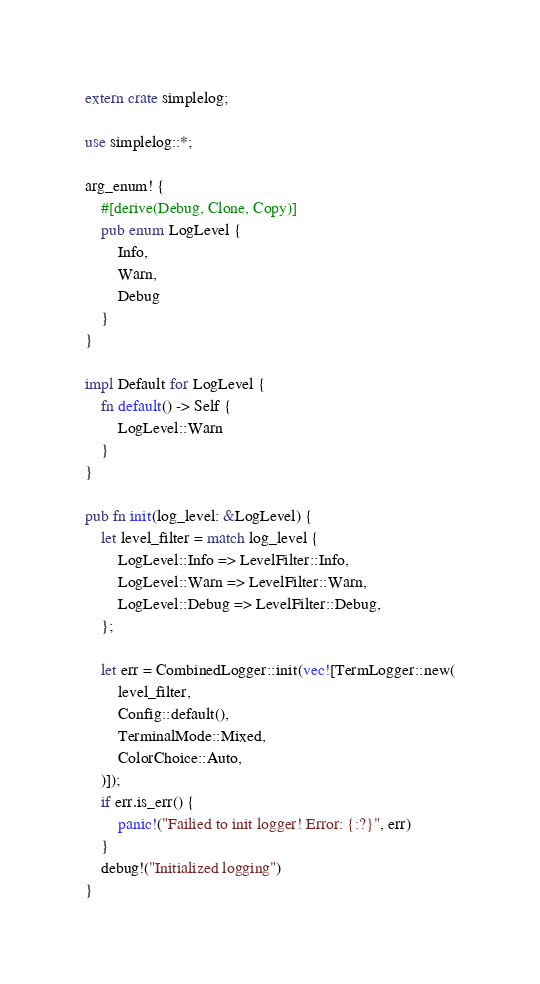Convert code to text. <code><loc_0><loc_0><loc_500><loc_500><_Rust_>extern crate simplelog;

use simplelog::*;

arg_enum! {
    #[derive(Debug, Clone, Copy)]
    pub enum LogLevel {
        Info,
        Warn,
        Debug
    }
}

impl Default for LogLevel {
    fn default() -> Self {
        LogLevel::Warn
    }
}

pub fn init(log_level: &LogLevel) {
    let level_filter = match log_level {
        LogLevel::Info => LevelFilter::Info,
        LogLevel::Warn => LevelFilter::Warn,
        LogLevel::Debug => LevelFilter::Debug,
    };

    let err = CombinedLogger::init(vec![TermLogger::new(
        level_filter,
        Config::default(),
        TerminalMode::Mixed,
        ColorChoice::Auto,
    )]);
    if err.is_err() {
        panic!("Failied to init logger! Error: {:?}", err)
    }
    debug!("Initialized logging")
}
</code> 